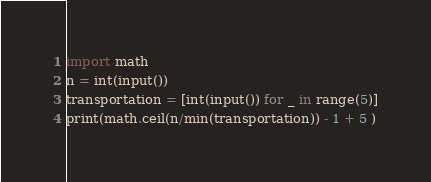<code> <loc_0><loc_0><loc_500><loc_500><_Python_>import math
n = int(input())
transportation = [int(input()) for _ in range(5)]
print(math.ceil(n/min(transportation)) - 1 + 5 )</code> 